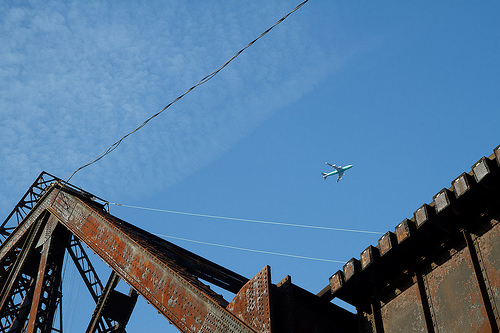Please provide a short description for this region: [0.09, 0.17, 0.24, 0.29]. A patch of white clouds drifting in the sky. 